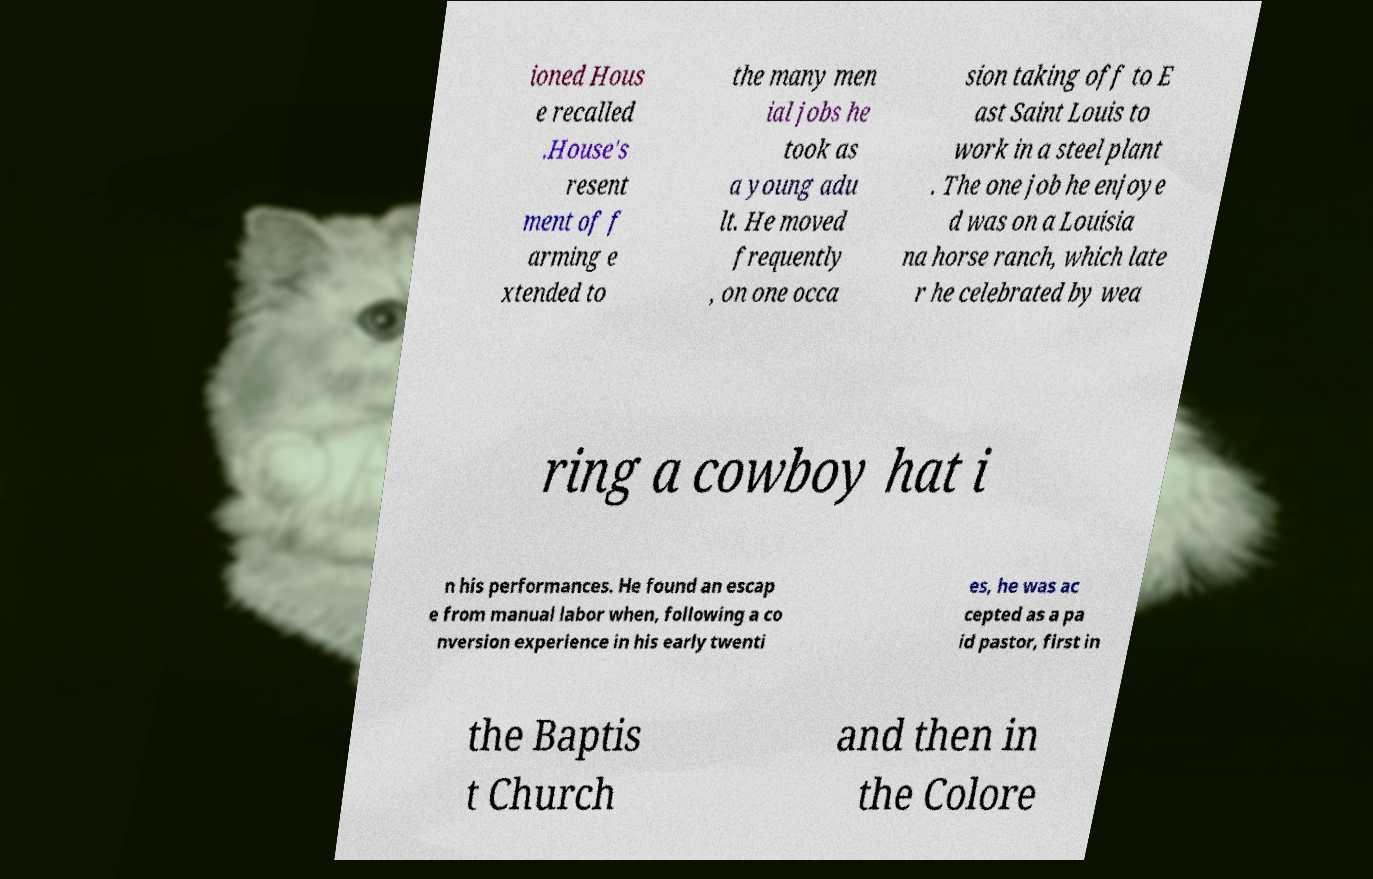Could you extract and type out the text from this image? ioned Hous e recalled .House's resent ment of f arming e xtended to the many men ial jobs he took as a young adu lt. He moved frequently , on one occa sion taking off to E ast Saint Louis to work in a steel plant . The one job he enjoye d was on a Louisia na horse ranch, which late r he celebrated by wea ring a cowboy hat i n his performances. He found an escap e from manual labor when, following a co nversion experience in his early twenti es, he was ac cepted as a pa id pastor, first in the Baptis t Church and then in the Colore 